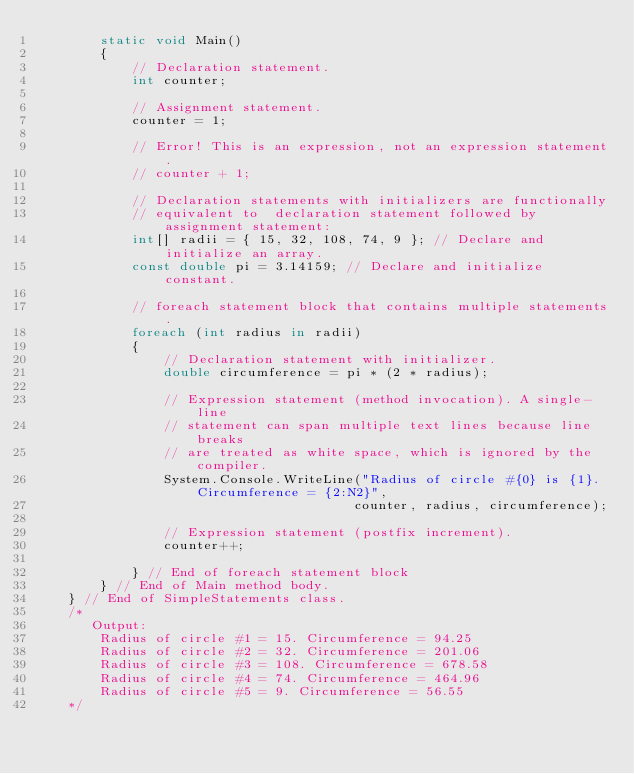<code> <loc_0><loc_0><loc_500><loc_500><_C#_>        static void Main()
        {
            // Declaration statement.
            int counter;

            // Assignment statement.
            counter = 1;

            // Error! This is an expression, not an expression statement.
            // counter + 1; 

            // Declaration statements with initializers are functionally
            // equivalent to  declaration statement followed by assignment statement:         
            int[] radii = { 15, 32, 108, 74, 9 }; // Declare and initialize an array.
            const double pi = 3.14159; // Declare and initialize  constant.          

            // foreach statement block that contains multiple statements.
            foreach (int radius in radii)
            {
                // Declaration statement with initializer.
                double circumference = pi * (2 * radius);

                // Expression statement (method invocation). A single-line
                // statement can span multiple text lines because line breaks
                // are treated as white space, which is ignored by the compiler.
                System.Console.WriteLine("Radius of circle #{0} is {1}. Circumference = {2:N2}",
                                        counter, radius, circumference);

                // Expression statement (postfix increment).
                counter++;

            } // End of foreach statement block
        } // End of Main method body.
    } // End of SimpleStatements class.
    /*
       Output:
        Radius of circle #1 = 15. Circumference = 94.25
        Radius of circle #2 = 32. Circumference = 201.06
        Radius of circle #3 = 108. Circumference = 678.58
        Radius of circle #4 = 74. Circumference = 464.96
        Radius of circle #5 = 9. Circumference = 56.55
    */</code> 